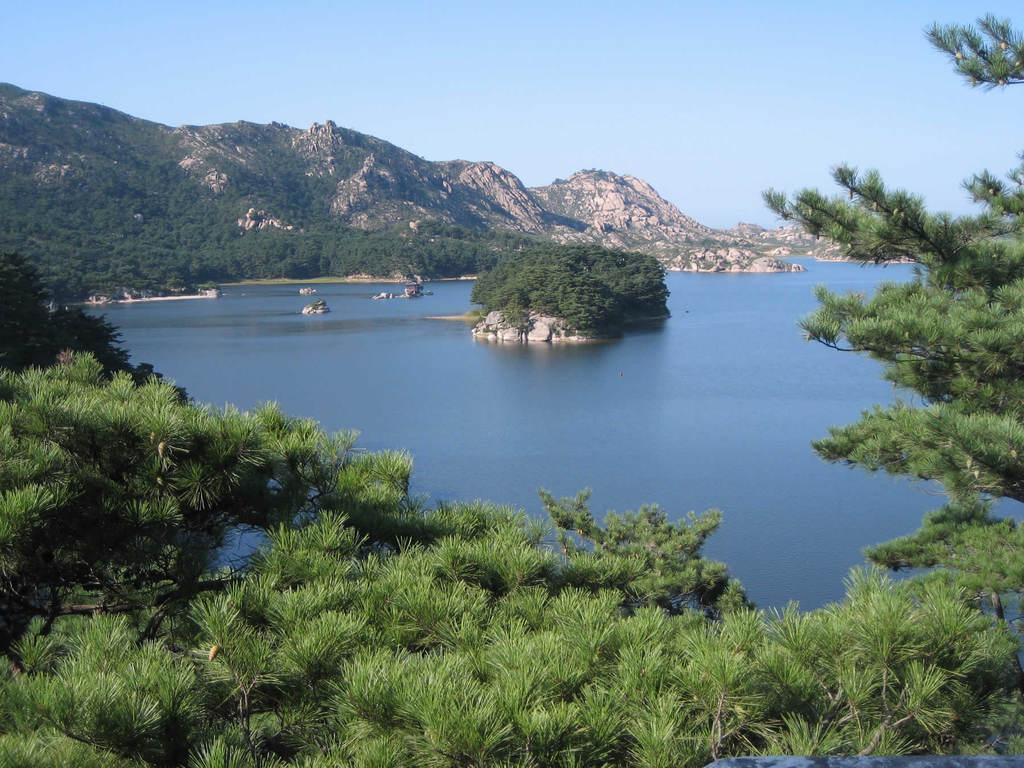Could you give a brief overview of what you see in this image? In the center of the image we can see a lake. At the bottom there are trees. In the background there are hills and sky. 